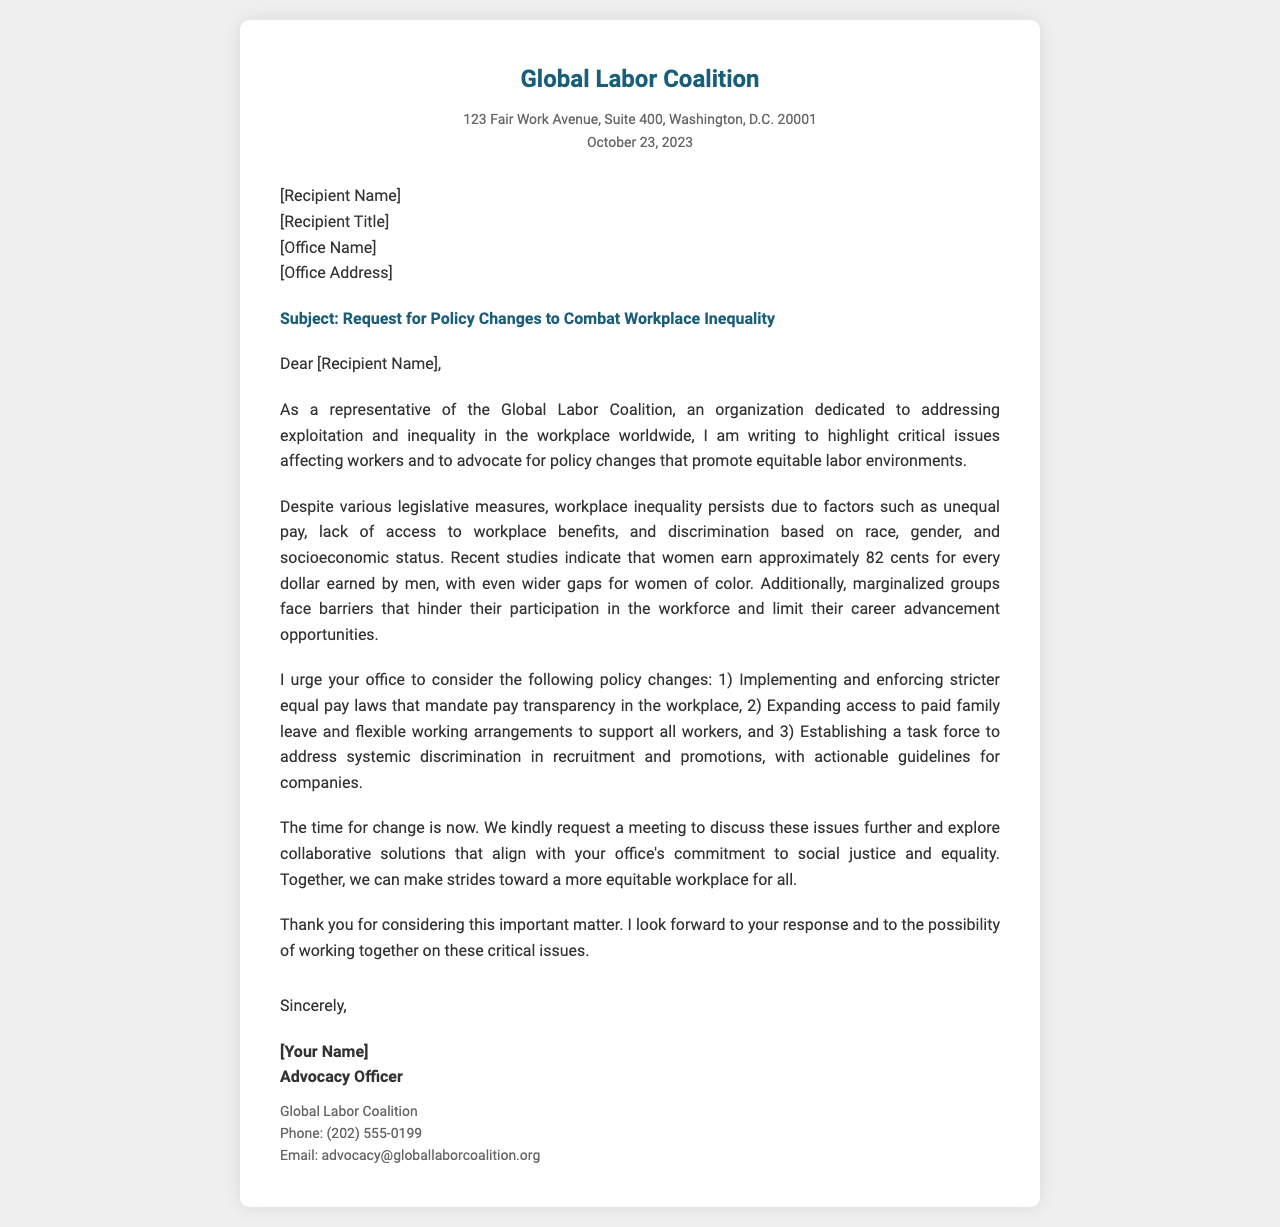What is the name of the organization sending the letter? The name of the organization is mentioned in the header of the letter.
Answer: Global Labor Coalition What is the address of the organization? The full address is provided in the letter's header.
Answer: 123 Fair Work Avenue, Suite 400, Washington, D.C. 20001 What date is on the letter? The date in the letter indicates when it was written.
Answer: October 23, 2023 What are the three policy changes being urged? The letter lists three specific policy changes in one of its paragraphs.
Answer: 1) Implementing stricter equal pay laws, 2) Expanding access to paid family leave, 3) Establishing a task force Who is the target recipient of the letter? The document indicates a placeholder for the recipient's name and title.
Answer: [Recipient Name] What is the signature title of the sender? The signature section includes the title of the person writing the letter.
Answer: Advocacy Officer What is the primary subject of the letter? The subject line specifically mentions the intention of the letter.
Answer: Request for Policy Changes to Combat Workplace Inequality What challenges do marginalized groups face according to the letter? The letter explains some obstacles faced by marginalized groups.
Answer: Barriers to participation and career advancement What is the phone number listed for contact? The contact details included in the letter state the phone number for communication.
Answer: (202) 555-0199 